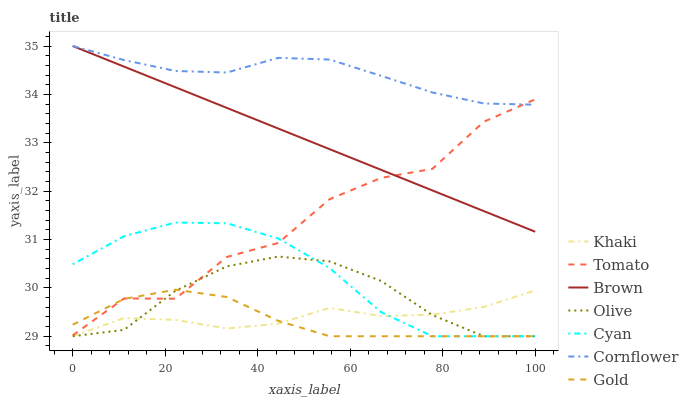Does Brown have the minimum area under the curve?
Answer yes or no. No. Does Brown have the maximum area under the curve?
Answer yes or no. No. Is Khaki the smoothest?
Answer yes or no. No. Is Khaki the roughest?
Answer yes or no. No. Does Brown have the lowest value?
Answer yes or no. No. Does Khaki have the highest value?
Answer yes or no. No. Is Khaki less than Cornflower?
Answer yes or no. Yes. Is Brown greater than Gold?
Answer yes or no. Yes. Does Khaki intersect Cornflower?
Answer yes or no. No. 